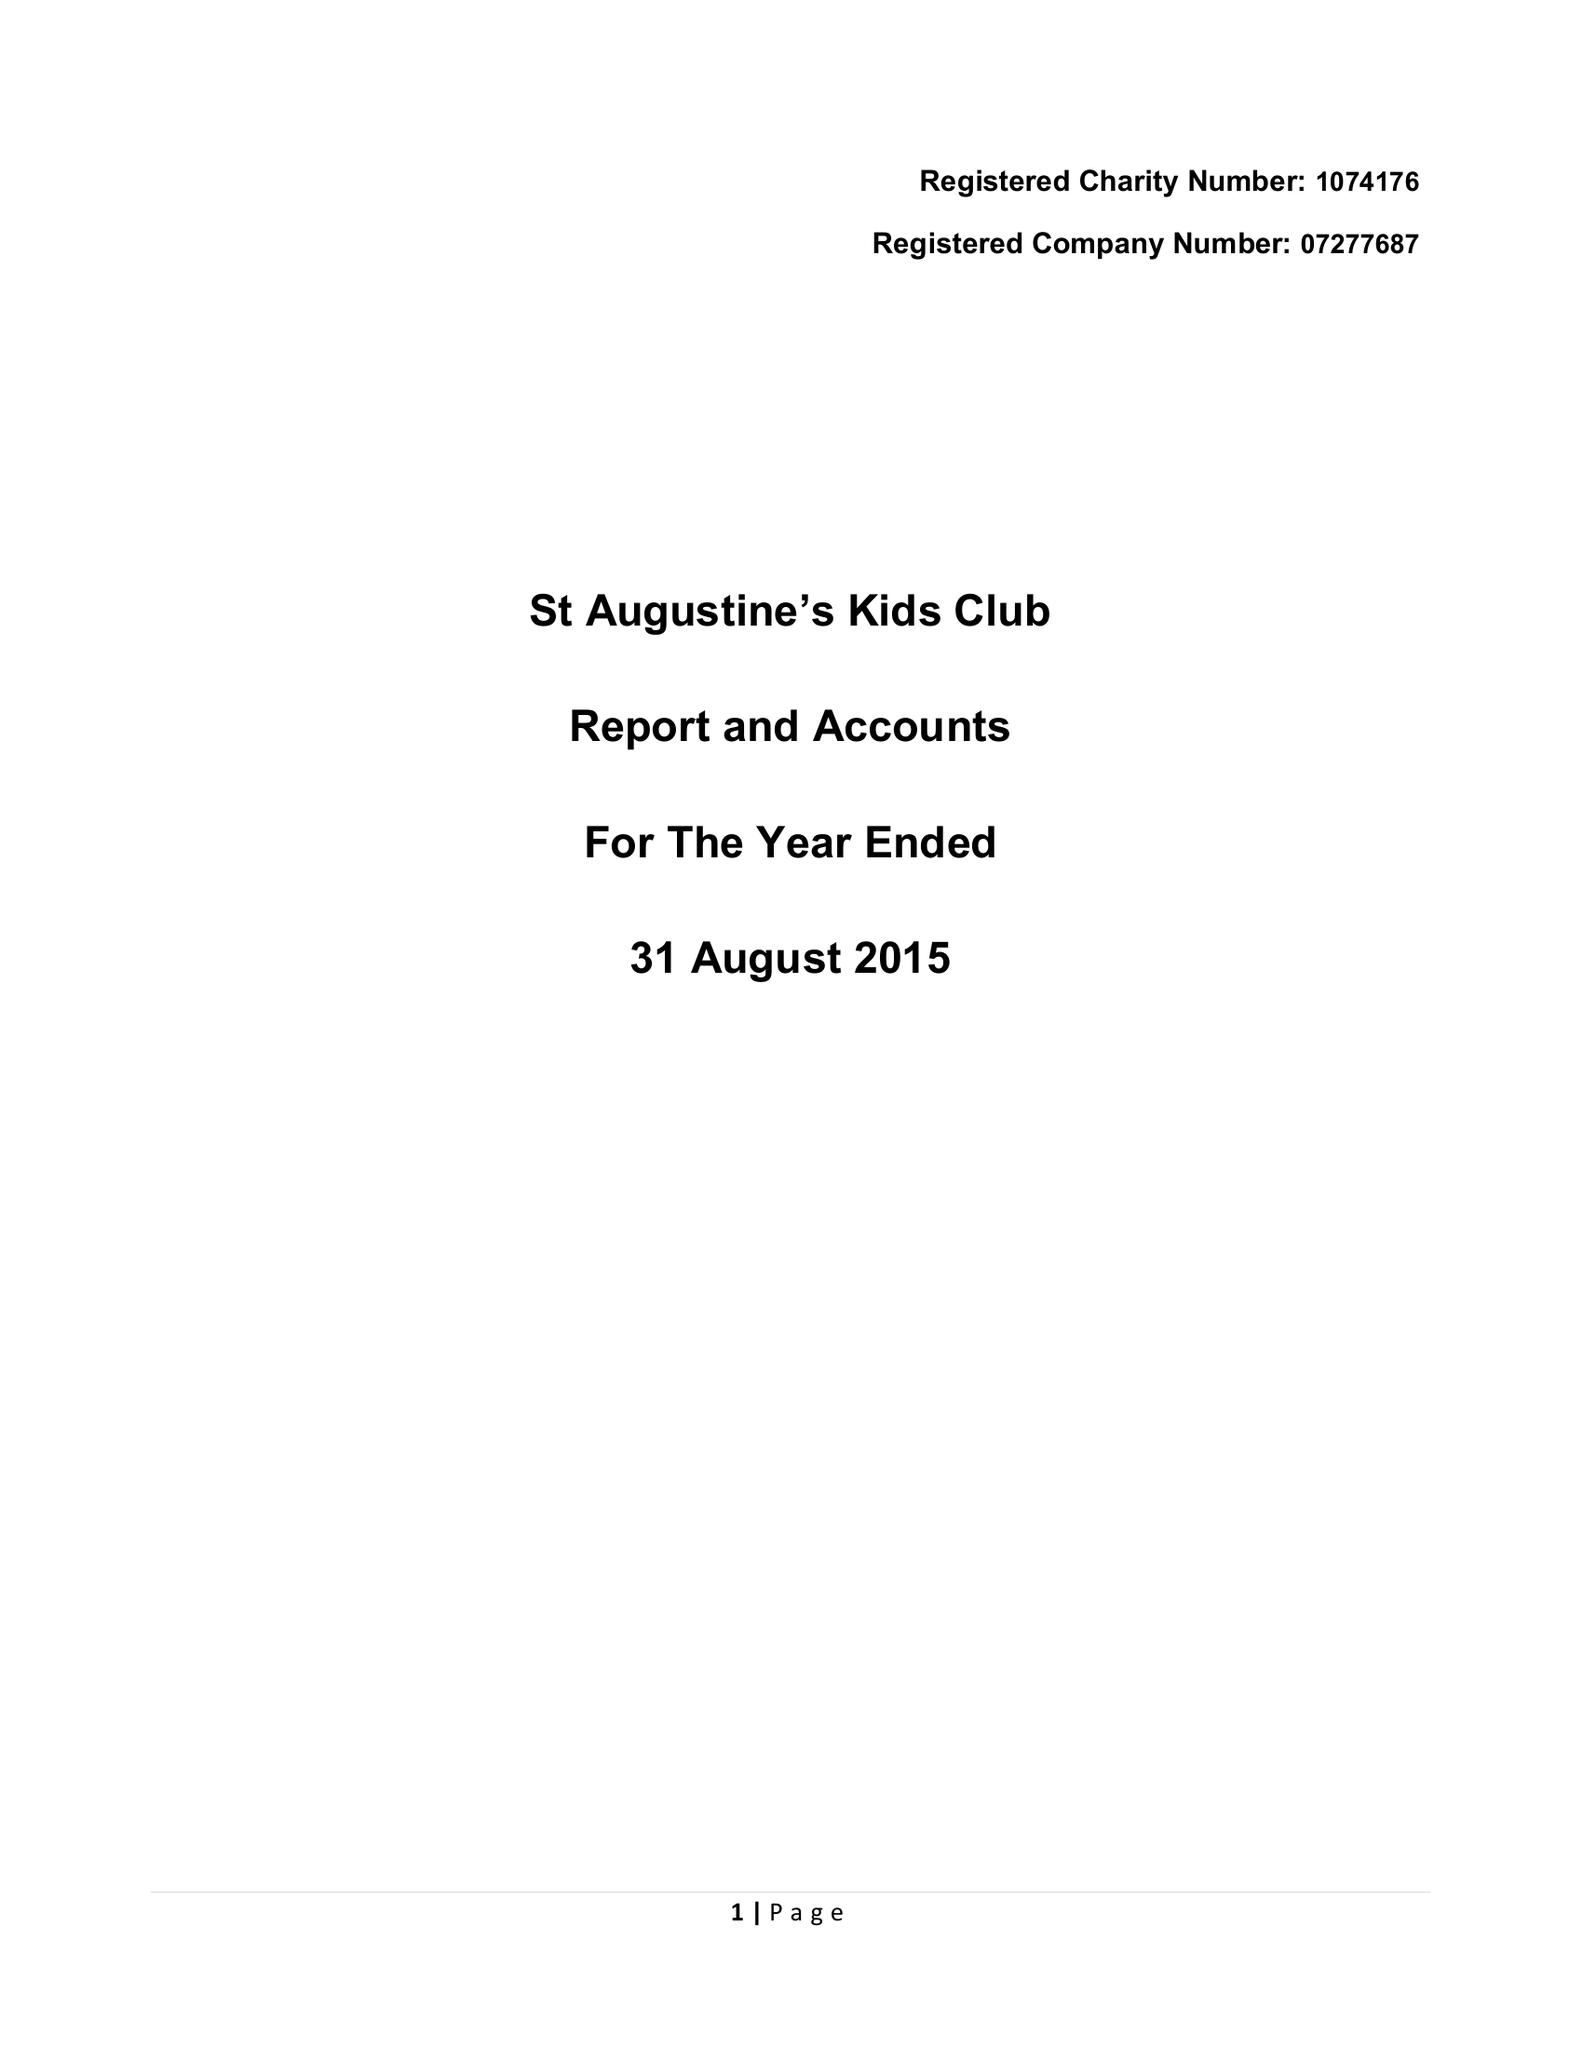What is the value for the income_annually_in_british_pounds?
Answer the question using a single word or phrase. 109041.00 